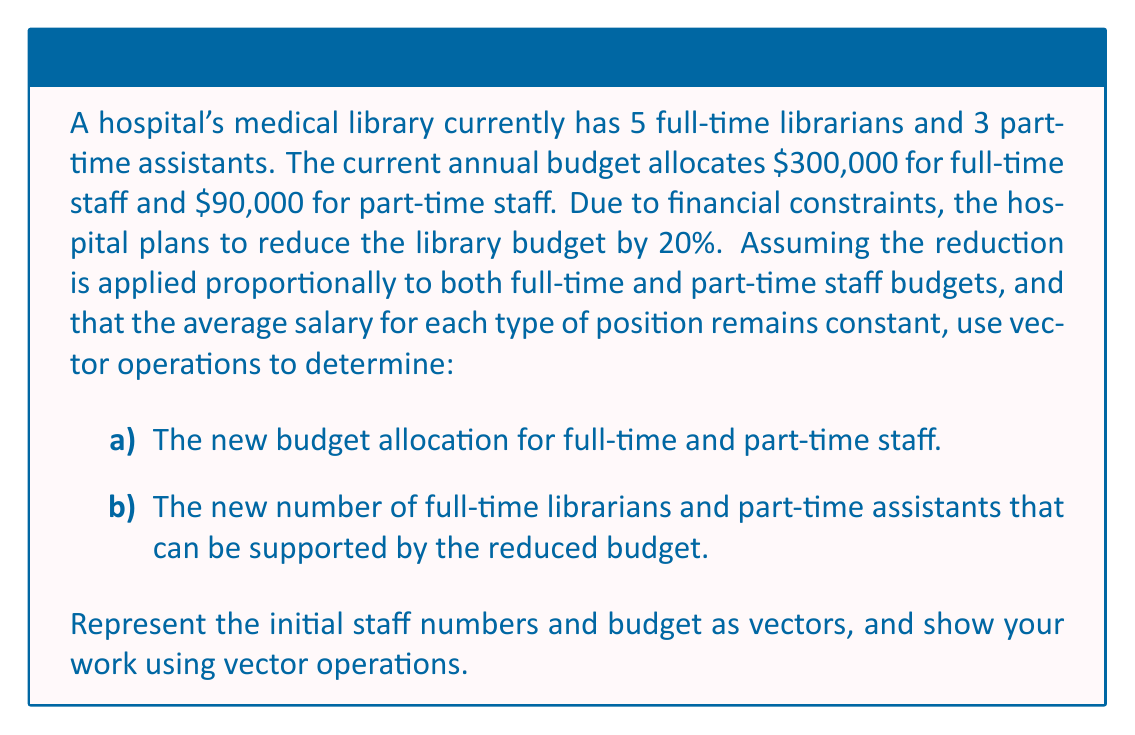Could you help me with this problem? Let's approach this problem step by step using vector operations:

1) First, let's define our initial vectors:

   Staff vector: $\mathbf{s} = \begin{pmatrix} 5 \\ 3 \end{pmatrix}$ (5 full-time, 3 part-time)
   Budget vector: $\mathbf{b} = \begin{pmatrix} 300000 \\ 90000 \end{pmatrix}$ ($300,000 for full-time, $90,000 for part-time)

2) Calculate the average salary for each type of position:

   Full-time: $\frac{300000}{5} = 60000$
   Part-time: $\frac{90000}{3} = 30000$

   Salary vector: $\mathbf{v} = \begin{pmatrix} 60000 \\ 30000 \end{pmatrix}$

3) To reduce the budget by 20%, we multiply the budget vector by 0.8:

   New budget vector: $\mathbf{b_{new}} = 0.8 \cdot \mathbf{b} = 0.8 \begin{pmatrix} 300000 \\ 90000 \end{pmatrix} = \begin{pmatrix} 240000 \\ 72000 \end{pmatrix}$

4) To find the new number of staff, we divide the new budget vector by the salary vector:

   $\mathbf{s_{new}} = \mathbf{b_{new}} \oslash \mathbf{v} = \begin{pmatrix} 240000 \\ 72000 \end{pmatrix} \oslash \begin{pmatrix} 60000 \\ 30000 \end{pmatrix} = \begin{pmatrix} 4 \\ 2.4 \end{pmatrix}$

   Where $\oslash$ represents element-wise division.

5) Since we can't have fractional staff members, we need to round down to the nearest whole number:

   Final new staff vector: $\mathbf{s_{final}} = \begin{pmatrix} 4 \\ 2 \end{pmatrix}$

Therefore, the new budget can support 4 full-time librarians and 2 part-time assistants.
Answer: a) New budget allocation:
   Full-time staff: $240,000
   Part-time staff: $72,000

b) New staff numbers:
   4 full-time librarians
   2 part-time assistants 